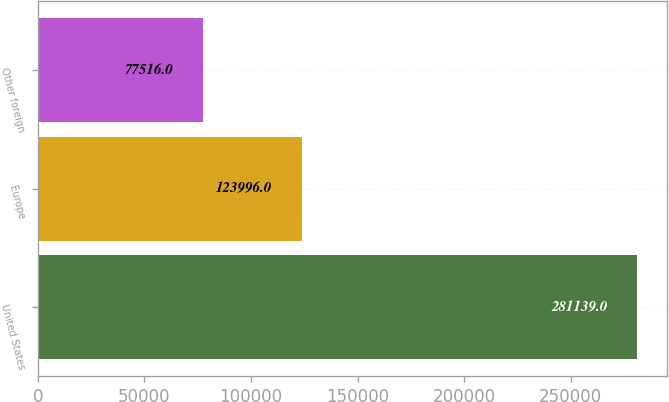Convert chart. <chart><loc_0><loc_0><loc_500><loc_500><bar_chart><fcel>United States<fcel>Europe<fcel>Other foreign<nl><fcel>281139<fcel>123996<fcel>77516<nl></chart> 